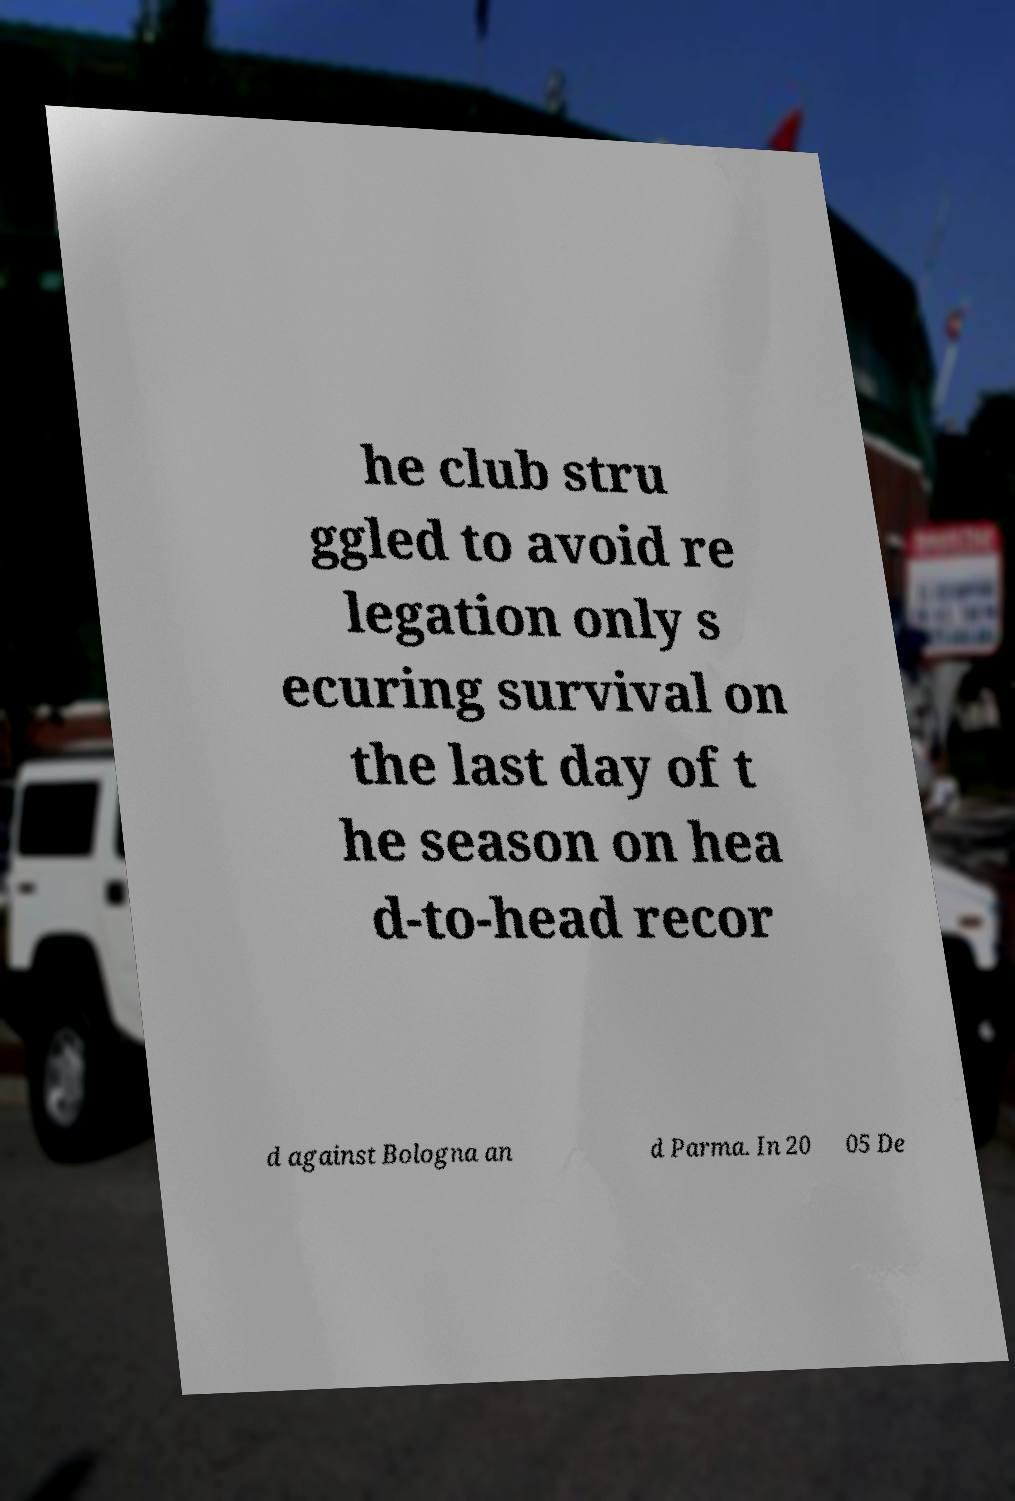Please read and relay the text visible in this image. What does it say? he club stru ggled to avoid re legation only s ecuring survival on the last day of t he season on hea d-to-head recor d against Bologna an d Parma. In 20 05 De 